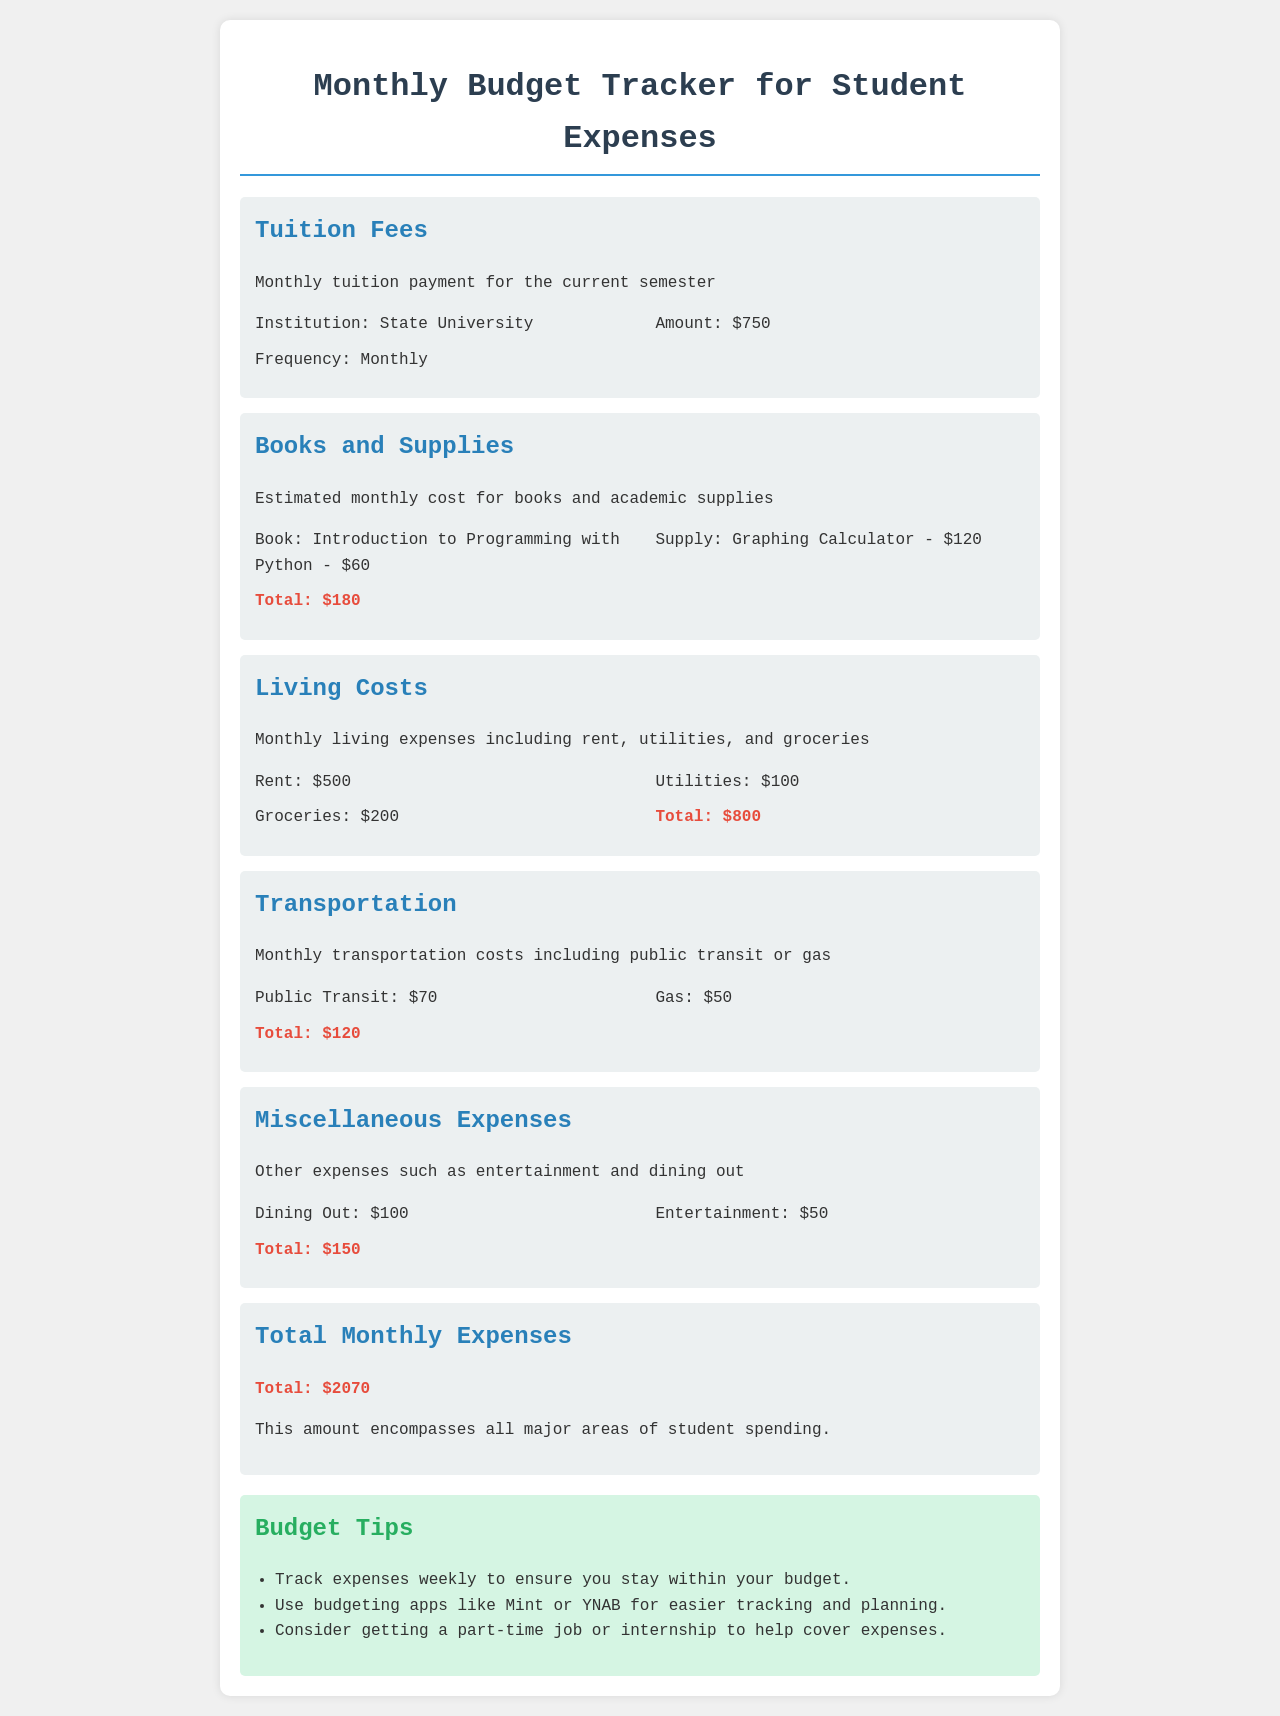What is the monthly tuition payment? The document states the monthly tuition payment for the current semester is $750.
Answer: $750 What is the total amount for books and supplies? The document lists the cost of books and supplies, with a total of $180.
Answer: $180 What is the sum of living costs? The living costs include rent, utilities, and groceries, totaling $800.
Answer: $800 How much is spent on transportation? The total transportation costs, including public transit and gas, amount to $120.
Answer: $120 What is included in miscellaneous expenses? The document mentions dining out and entertainment as the categories of miscellaneous expenses, which total $150.
Answer: $150 What are the total monthly expenses? The document provides the total monthly expenses as $2070, encompassing all major spending areas.
Answer: $2070 Which budgeting apps are recommended? The document recommends budgeting apps like Mint or YNAB for easier tracking.
Answer: Mint, YNAB What type of job is suggested to help cover expenses? The document suggests considering a part-time job or internship.
Answer: Part-time job or internship How often should expenses be tracked according to the tips? The document advises tracking expenses weekly.
Answer: Weekly 